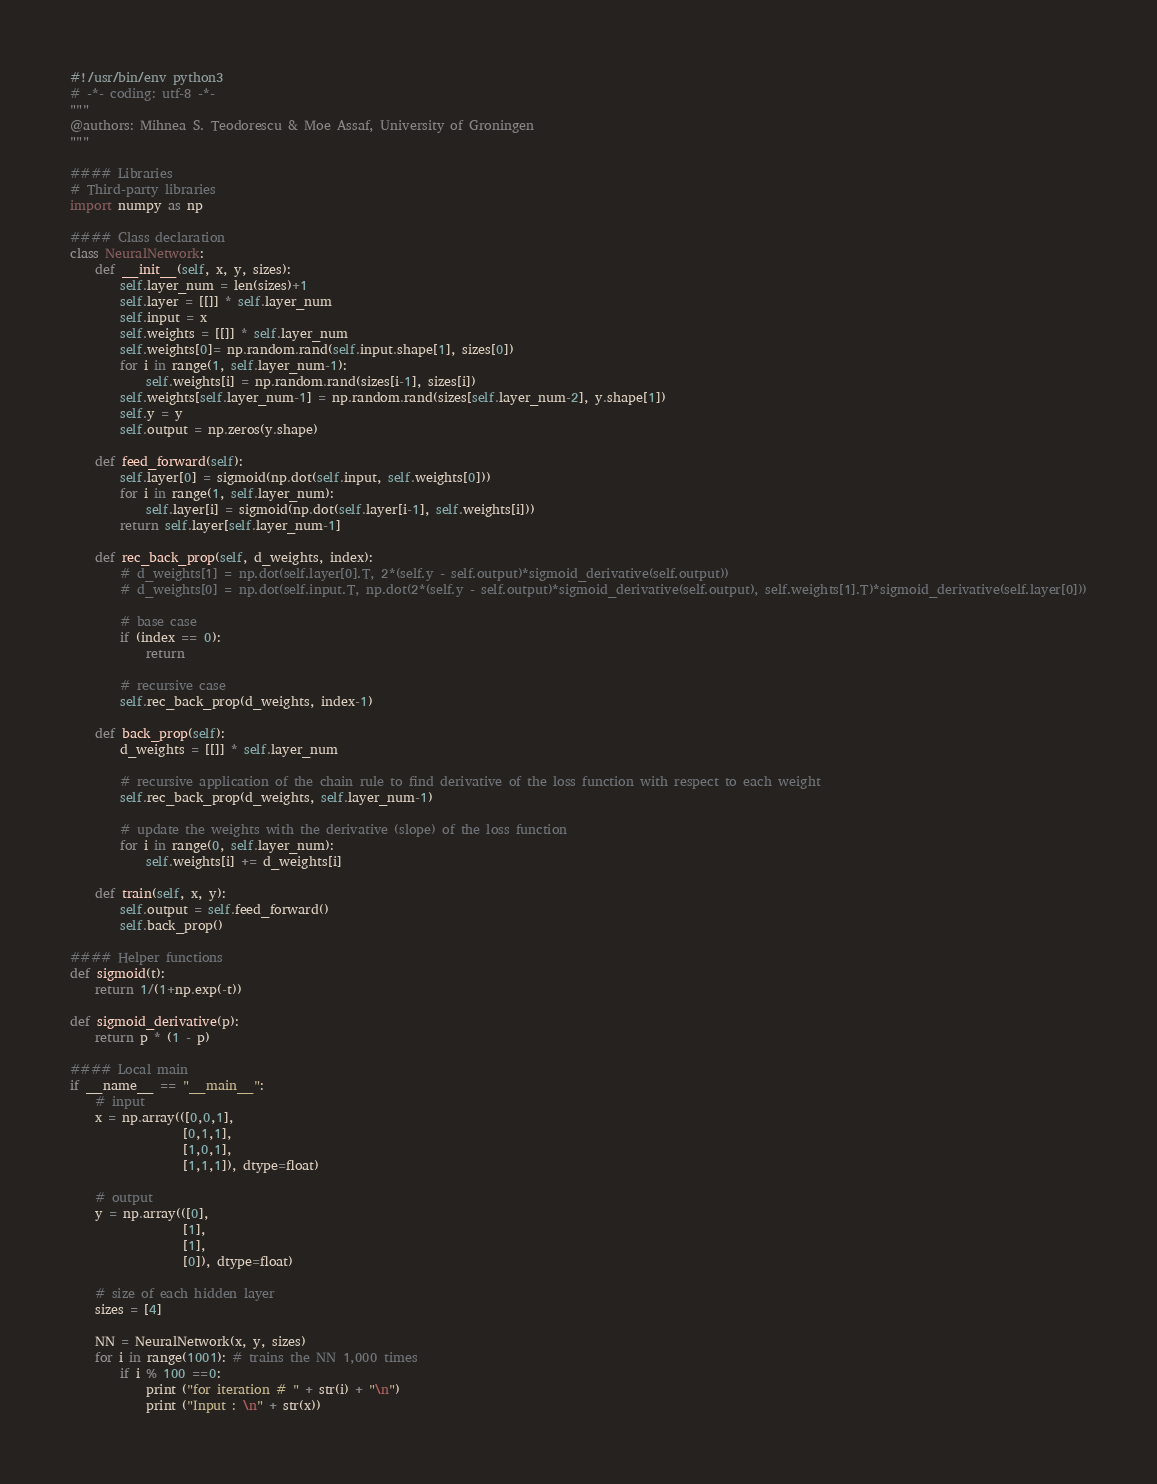Convert code to text. <code><loc_0><loc_0><loc_500><loc_500><_Python_>#!/usr/bin/env python3
# -*- coding: utf-8 -*-
"""
@authors: Mihnea S. Teodorescu & Moe Assaf, University of Groningen
"""

#### Libraries
# Third-party libraries
import numpy as np

#### Class declaration
class NeuralNetwork:
    def __init__(self, x, y, sizes):
        self.layer_num = len(sizes)+1
        self.layer = [[]] * self.layer_num
        self.input = x
        self.weights = [[]] * self.layer_num
        self.weights[0]= np.random.rand(self.input.shape[1], sizes[0])
        for i in range(1, self.layer_num-1):
            self.weights[i] = np.random.rand(sizes[i-1], sizes[i])
        self.weights[self.layer_num-1] = np.random.rand(sizes[self.layer_num-2], y.shape[1])
        self.y = y
        self.output = np.zeros(y.shape)

    def feed_forward(self):
        self.layer[0] = sigmoid(np.dot(self.input, self.weights[0]))
        for i in range(1, self.layer_num):
            self.layer[i] = sigmoid(np.dot(self.layer[i-1], self.weights[i]))
        return self.layer[self.layer_num-1]
    
    def rec_back_prop(self, d_weights, index):
        # d_weights[1] = np.dot(self.layer[0].T, 2*(self.y - self.output)*sigmoid_derivative(self.output))
        # d_weights[0] = np.dot(self.input.T, np.dot(2*(self.y - self.output)*sigmoid_derivative(self.output), self.weights[1].T)*sigmoid_derivative(self.layer[0]))
        
        # base case
        if (index == 0):
            return

        # recursive case
        self.rec_back_prop(d_weights, index-1)
    
    def back_prop(self):
        d_weights = [[]] * self.layer_num
        
        # recursive application of the chain rule to find derivative of the loss function with respect to each weight
        self.rec_back_prop(d_weights, self.layer_num-1)

        # update the weights with the derivative (slope) of the loss function
        for i in range(0, self.layer_num):
            self.weights[i] += d_weights[i]

    def train(self, x, y):
        self.output = self.feed_forward()
        self.back_prop()

#### Helper functions
def sigmoid(t):
    return 1/(1+np.exp(-t))

def sigmoid_derivative(p):
    return p * (1 - p)

#### Local main
if __name__ == "__main__":
    # input
    x = np.array(([0,0,1], 
                  [0,1,1],
                  [1,0,1],
                  [1,1,1]), dtype=float)
    
    # output
    y = np.array(([0],
                  [1],
                  [1],
                  [0]), dtype=float)

    # size of each hidden layer
    sizes = [4]

    NN = NeuralNetwork(x, y, sizes)
    for i in range(1001): # trains the NN 1,000 times
        if i % 100 ==0: 
            print ("for iteration # " + str(i) + "\n")
            print ("Input : \n" + str(x))</code> 